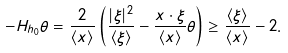<formula> <loc_0><loc_0><loc_500><loc_500>- H _ { h _ { 0 } } \theta = \frac { 2 } { \langle x \rangle } \left ( \frac { | \xi | ^ { 2 } } { \langle \xi \rangle } - \frac { x \cdot \xi } { \langle x \rangle } \theta \right ) \geq \frac { \langle \xi \rangle } { \langle x \rangle } - 2 .</formula> 